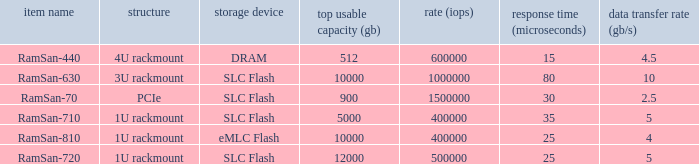What is the Input/output operations per second for the emlc flash? 400000.0. 